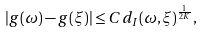<formula> <loc_0><loc_0><loc_500><loc_500>| g ( \omega ) - g ( \xi ) | \leq C d _ { I } ( \omega , \xi ) ^ { \frac { 1 } { 2 K } } ,</formula> 